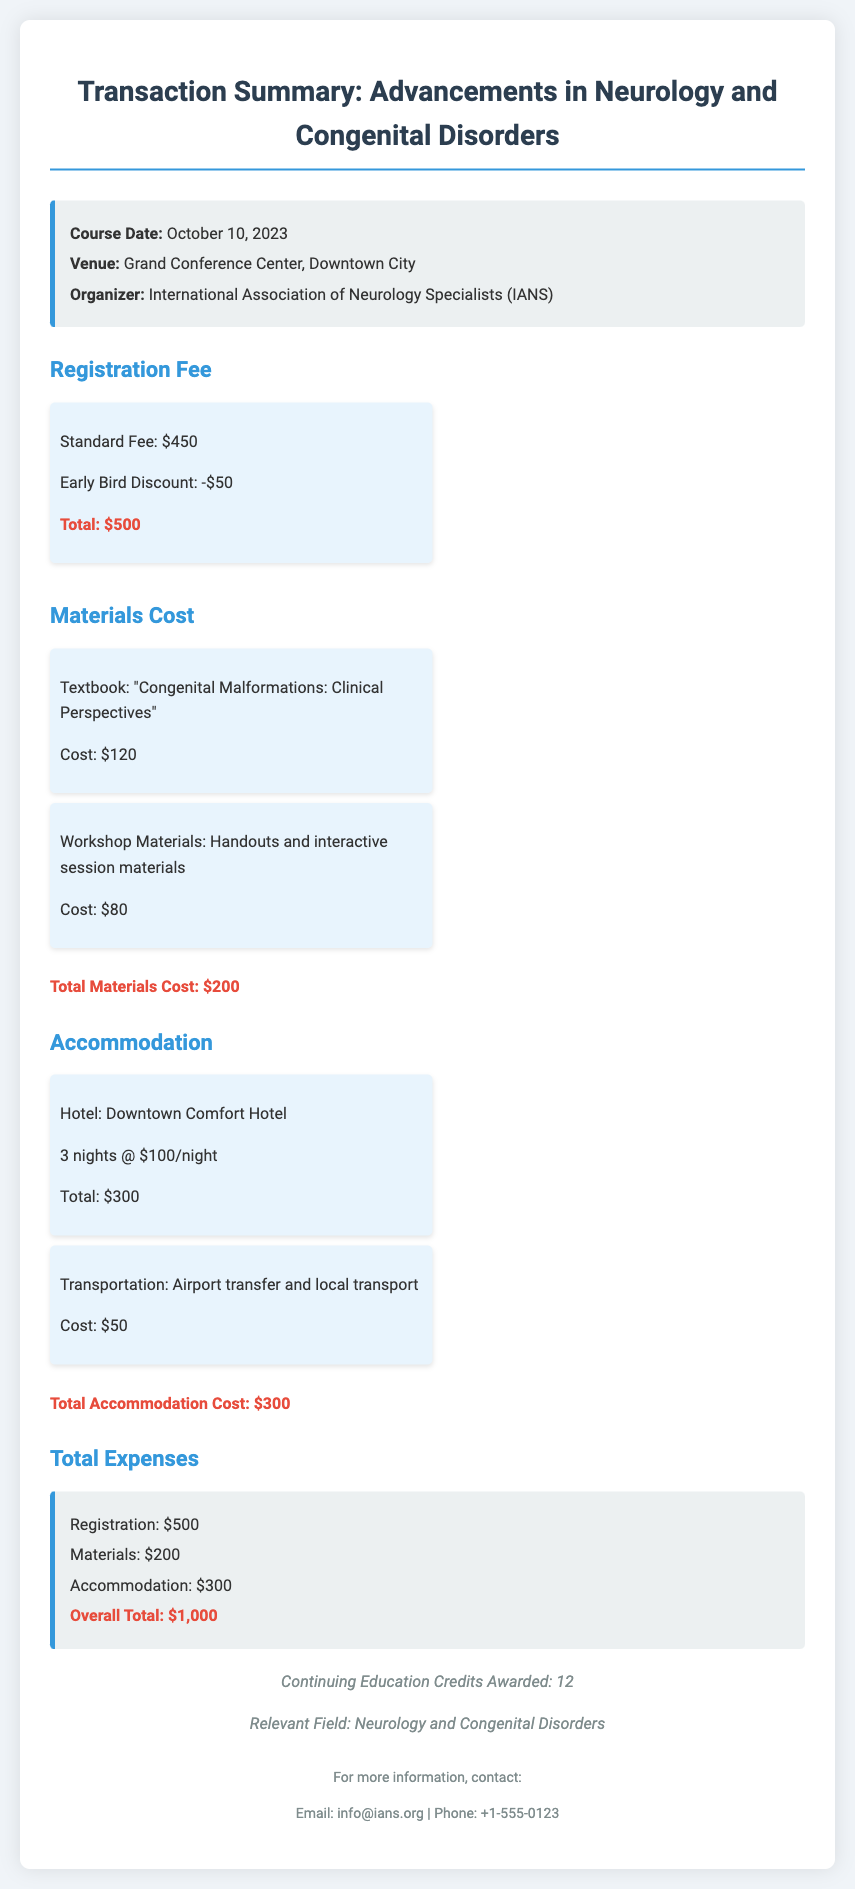What is the course date? The course date is explicitly mentioned in the document.
Answer: October 10, 2023 Who organized the course? The organizer of the course is stated in the document.
Answer: International Association of Neurology Specialists (IANS) What is the total fee after the early bird discount? The total fee is calculated from the standard fee and early bird discount listed in the document.
Answer: $400 How much is the textbook cost? The cost of the textbook is specified in the materials cost section of the document.
Answer: $120 What is the total accommodation cost? The total accommodation cost is derived from the hotel and transportation costs provided in the document.
Answer: $350 How many continuing education credits were awarded? The number of credits awarded is mentioned towards the end of the document.
Answer: 12 What venue hosted the event? The venue details are provided in the information block within the document.
Answer: Grand Conference Center, Downtown City What is the total overall expense? The overall total is the sum of registration, materials, and accommodation costs in the document.
Answer: $1,000 